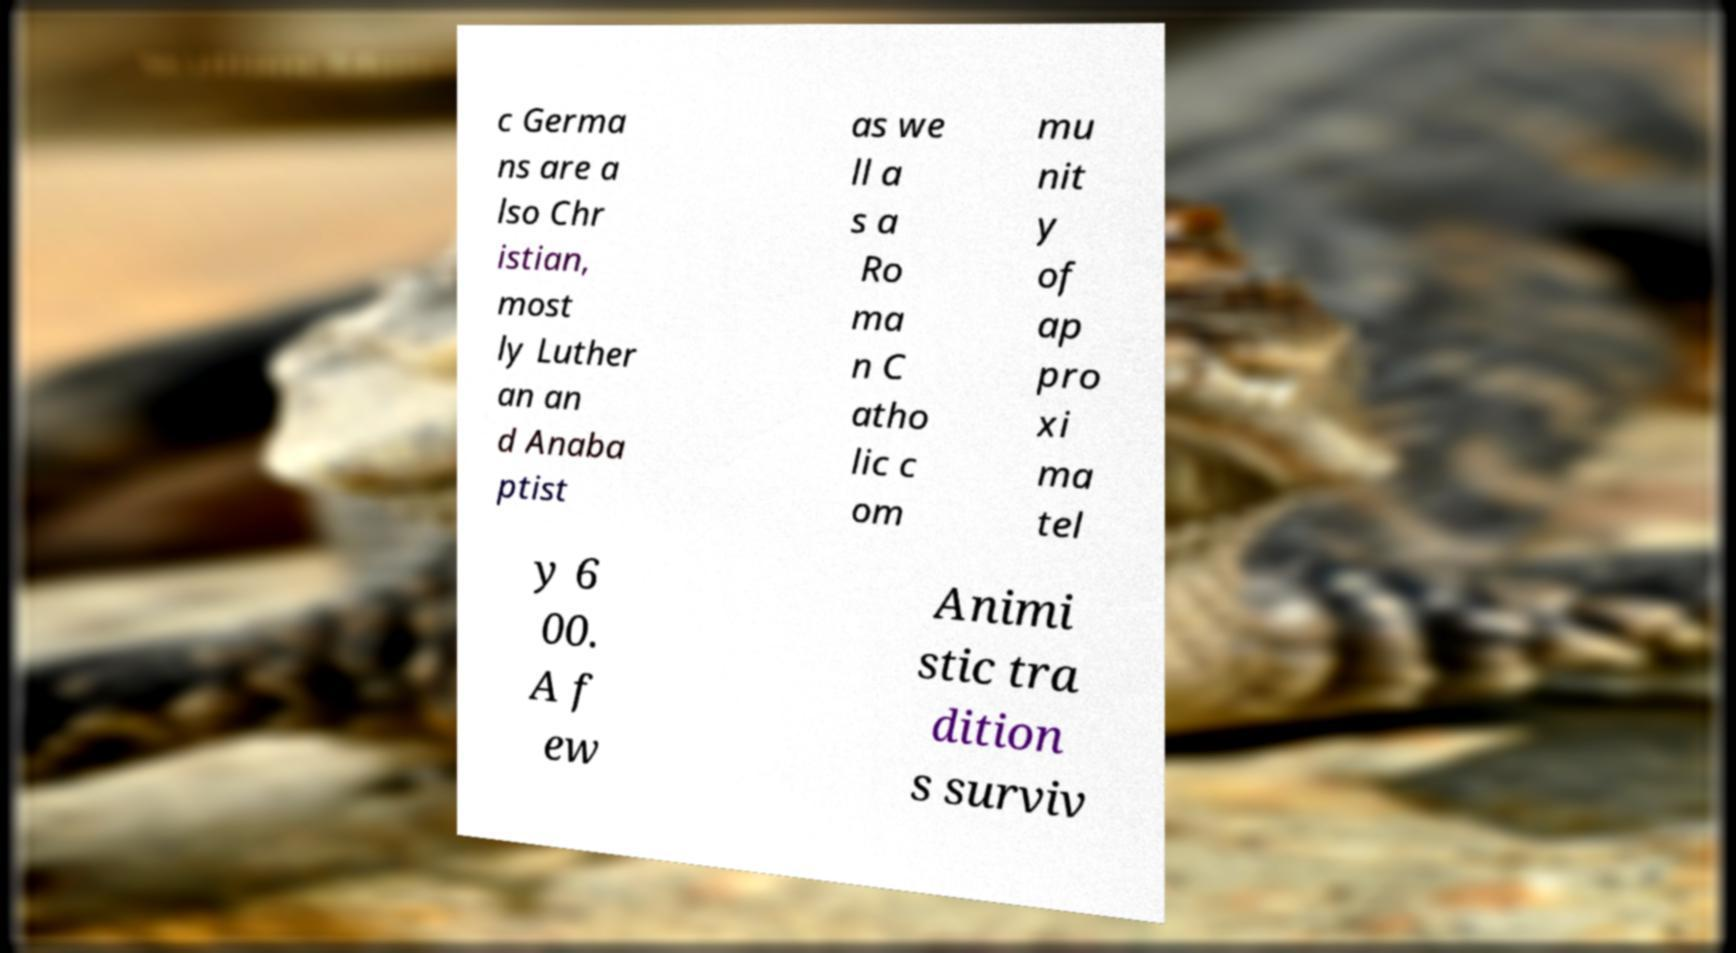Can you read and provide the text displayed in the image?This photo seems to have some interesting text. Can you extract and type it out for me? c Germa ns are a lso Chr istian, most ly Luther an an d Anaba ptist as we ll a s a Ro ma n C atho lic c om mu nit y of ap pro xi ma tel y 6 00. A f ew Animi stic tra dition s surviv 